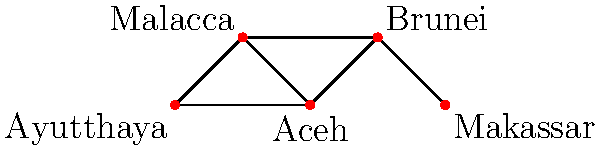Given the network diagram representing major trade hubs in pre-colonial Southeast Asia, what is the minimum number of trade routes that need to be disrupted to completely isolate Aceh from all other trade centers? To answer this question, we need to analyze the connectivity of Aceh in the network:

1. Identify Aceh's connections:
   - Aceh is directly connected to Ayutthaya, Malacca, and Brunei.

2. Count the number of edges (trade routes) connected to Aceh:
   - There are 3 edges connecting Aceh to other nodes.

3. Consider the concept of minimum cut:
   - In graph theory, the minimum cut is the smallest number of edges that, when removed, disconnect a node from the rest of the network.

4. Analyze alternative paths:
   - There are no alternative paths to reach Aceh other than the direct connections.

5. Determine the minimum number of routes to disrupt:
   - To isolate Aceh, all 3 of its direct connections must be severed.

6. Verify the solution:
   - If we remove these 3 edges, Aceh becomes completely isolated from all other trade centers in the network.

Therefore, the minimum number of trade routes that need to be disrupted to completely isolate Aceh is 3.
Answer: 3 